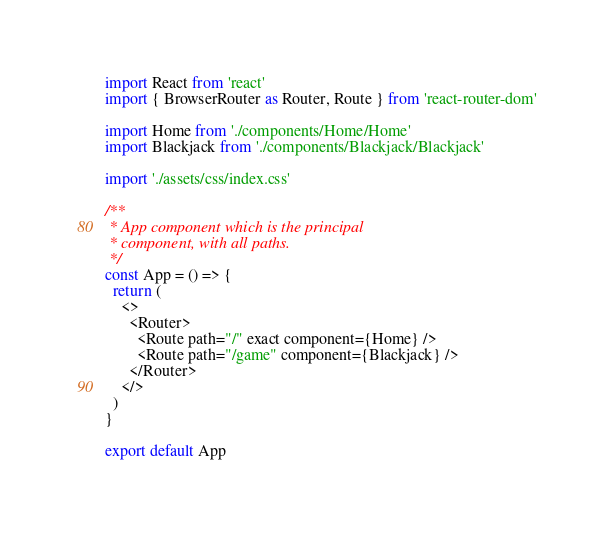<code> <loc_0><loc_0><loc_500><loc_500><_JavaScript_>import React from 'react'
import { BrowserRouter as Router, Route } from 'react-router-dom'

import Home from './components/Home/Home'
import Blackjack from './components/Blackjack/Blackjack'

import './assets/css/index.css'

/**
 * App component which is the principal
 * component, with all paths.
 */
const App = () => {
  return (
    <>
      <Router>
        <Route path="/" exact component={Home} />
        <Route path="/game" component={Blackjack} />
      </Router>
    </>
  )
}

export default App
</code> 